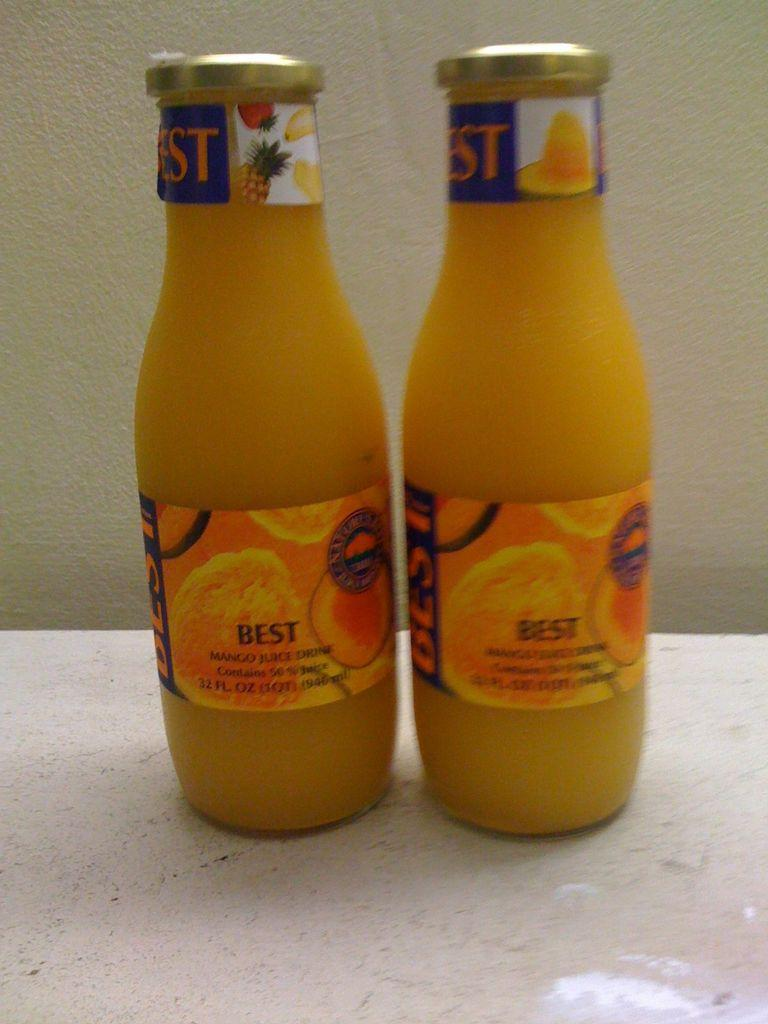<image>
Provide a brief description of the given image. Two bottles of Best juice side by side. 